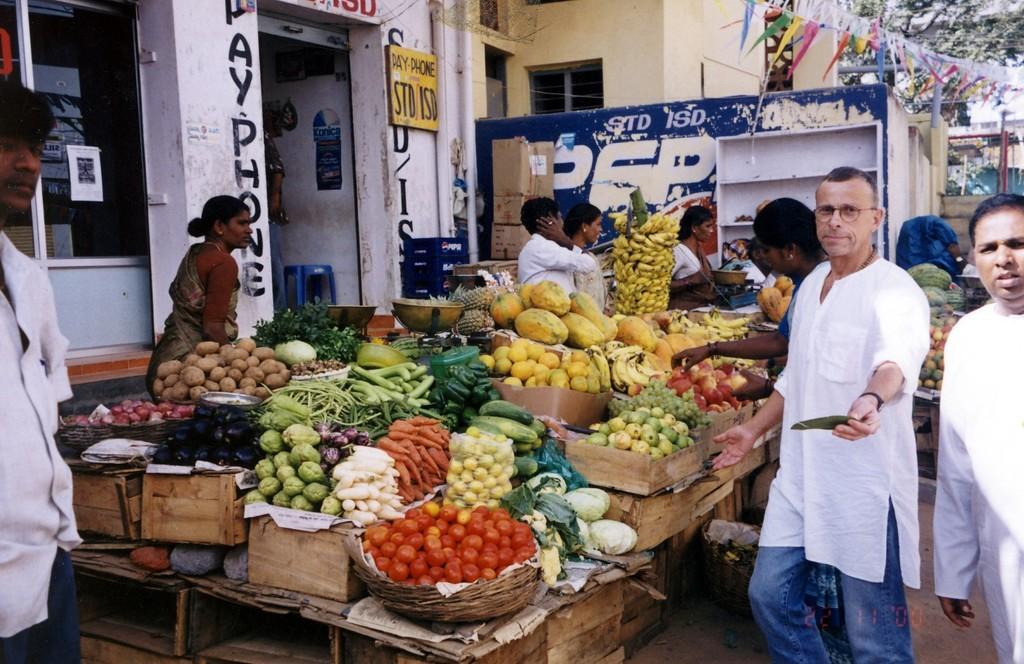Can you describe this image briefly? This picture is clicked in the market. The man in a white shirt who is wearing spectacles is holding a green color thing in his hand. In front of him, we see a table on which many baskets containing fruits and vegetables are placed. Behind the table, the woman in a saree is standing. The man and woman in white shirts are standing beside the table. Behind them, we see a wall in white color and a yellow board with some text written on it. The man on the left side is standing. On the right side, we see buildings and trees. 